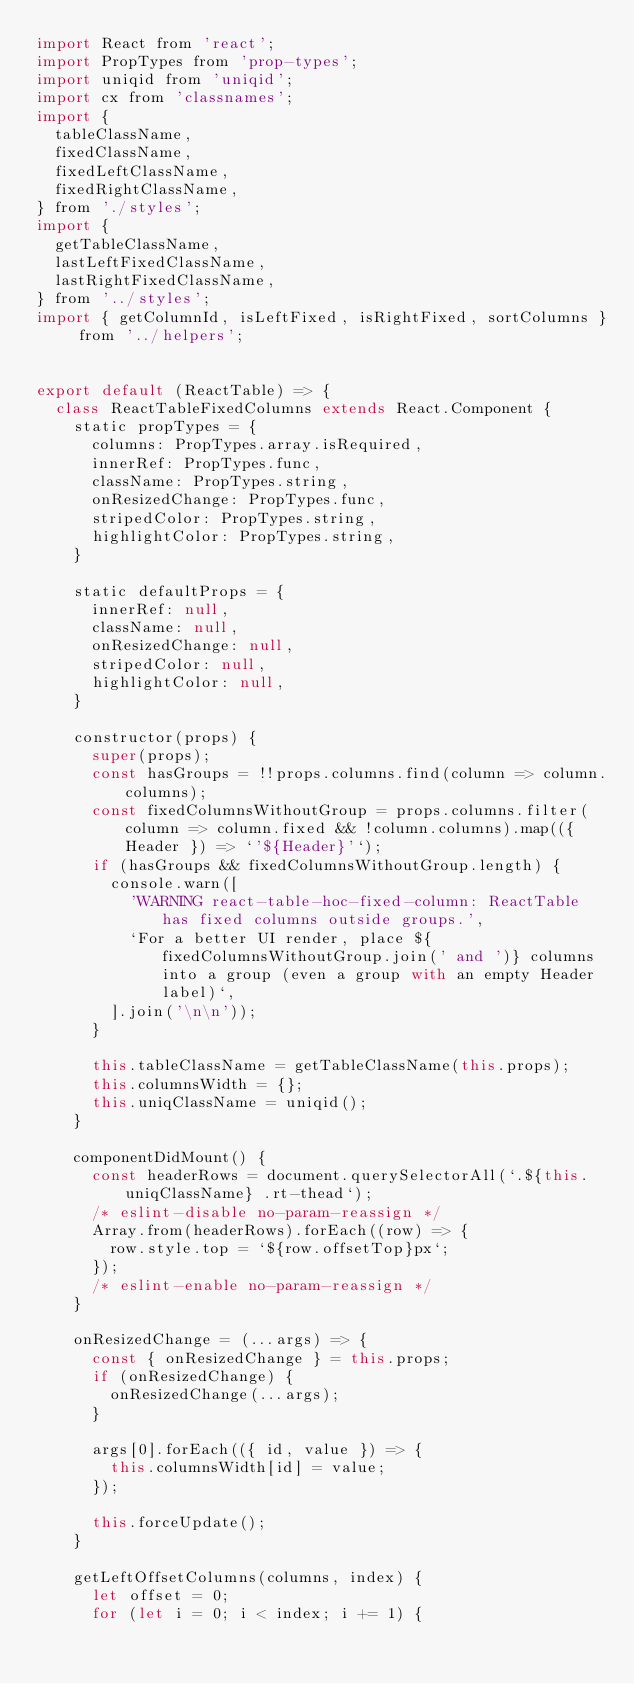Convert code to text. <code><loc_0><loc_0><loc_500><loc_500><_JavaScript_>import React from 'react';
import PropTypes from 'prop-types';
import uniqid from 'uniqid';
import cx from 'classnames';
import {
  tableClassName,
  fixedClassName,
  fixedLeftClassName,
  fixedRightClassName,
} from './styles';
import {
  getTableClassName,
  lastLeftFixedClassName,
  lastRightFixedClassName,
} from '../styles';
import { getColumnId, isLeftFixed, isRightFixed, sortColumns } from '../helpers';


export default (ReactTable) => {
  class ReactTableFixedColumns extends React.Component {
    static propTypes = {
      columns: PropTypes.array.isRequired,
      innerRef: PropTypes.func,
      className: PropTypes.string,
      onResizedChange: PropTypes.func,
      stripedColor: PropTypes.string,
      highlightColor: PropTypes.string,
    }

    static defaultProps = {
      innerRef: null,
      className: null,
      onResizedChange: null,
      stripedColor: null,
      highlightColor: null,
    }

    constructor(props) {
      super(props);
      const hasGroups = !!props.columns.find(column => column.columns);
      const fixedColumnsWithoutGroup = props.columns.filter(column => column.fixed && !column.columns).map(({ Header }) => `'${Header}'`);
      if (hasGroups && fixedColumnsWithoutGroup.length) {
        console.warn([
          'WARNING react-table-hoc-fixed-column: ReactTable has fixed columns outside groups.',
          `For a better UI render, place ${fixedColumnsWithoutGroup.join(' and ')} columns into a group (even a group with an empty Header label)`,
        ].join('\n\n'));
      }

      this.tableClassName = getTableClassName(this.props);
      this.columnsWidth = {};
      this.uniqClassName = uniqid();
    }

    componentDidMount() {
      const headerRows = document.querySelectorAll(`.${this.uniqClassName} .rt-thead`);
      /* eslint-disable no-param-reassign */
      Array.from(headerRows).forEach((row) => {
        row.style.top = `${row.offsetTop}px`;
      });
      /* eslint-enable no-param-reassign */
    }

    onResizedChange = (...args) => {
      const { onResizedChange } = this.props;
      if (onResizedChange) {
        onResizedChange(...args);
      }

      args[0].forEach(({ id, value }) => {
        this.columnsWidth[id] = value;
      });

      this.forceUpdate();
    }

    getLeftOffsetColumns(columns, index) {
      let offset = 0;
      for (let i = 0; i < index; i += 1) {</code> 